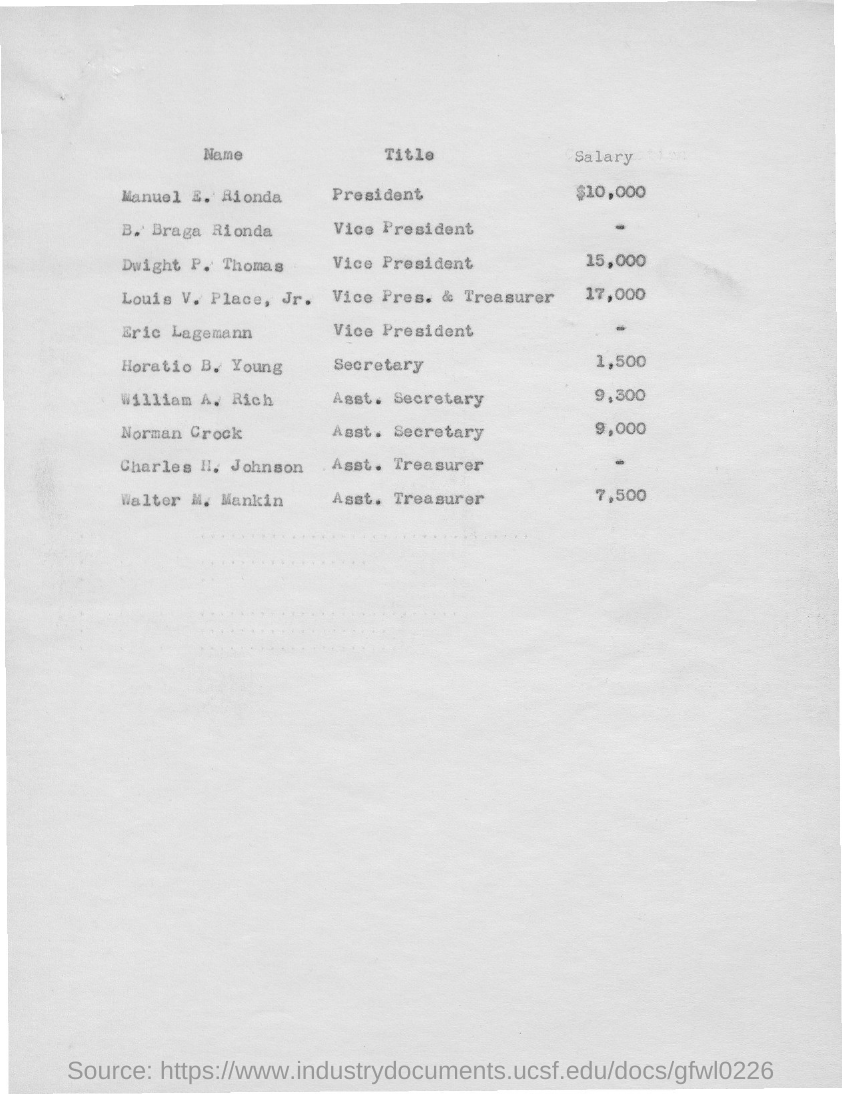Identify some key points in this picture. Charles H. Johnson is referred to as the Assistant Treasurer in the given page. Manuel E. Rionda's salary, as mentioned on the given page, is $10,000. Norman Rockwell was titled as Assistant Secretary in a given page. Walter M. Mankin was appointed the title of Assistant Treasurer, as mentioned in the provided page. The salary mentioned for Norman Crock is 9,000. 